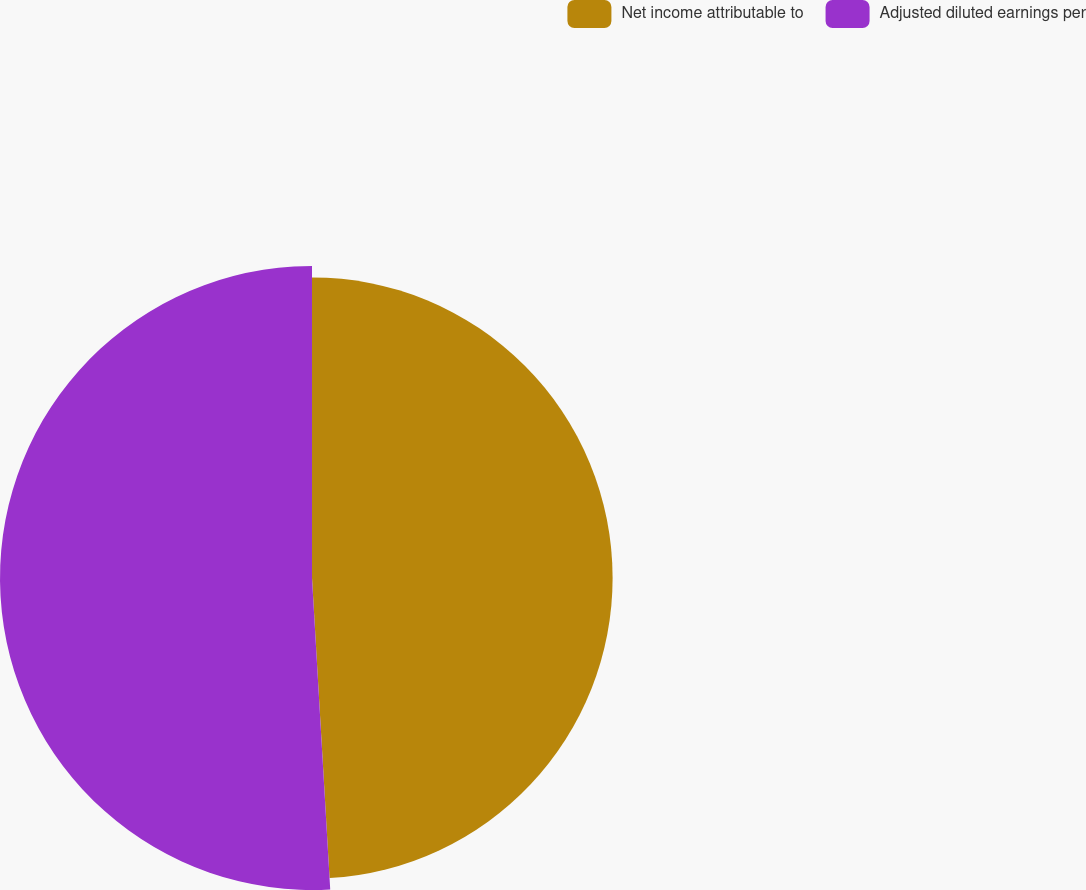Convert chart. <chart><loc_0><loc_0><loc_500><loc_500><pie_chart><fcel>Net income attributable to<fcel>Adjusted diluted earnings per<nl><fcel>49.07%<fcel>50.93%<nl></chart> 